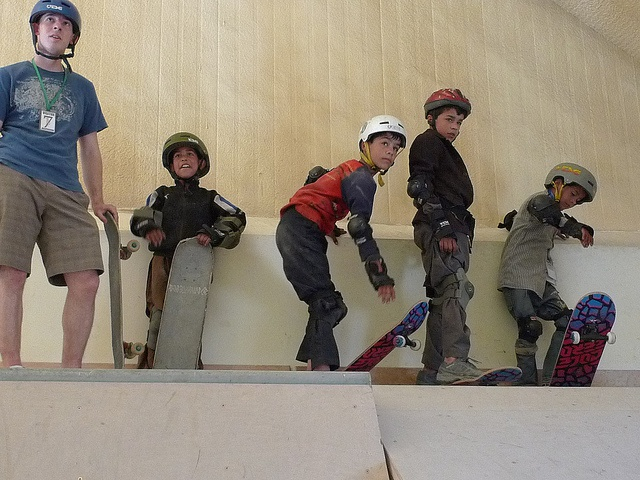Describe the objects in this image and their specific colors. I can see people in tan, gray, blue, and navy tones, people in tan, black, gray, and maroon tones, people in tan, black, and gray tones, people in tan, black, gray, and darkgray tones, and people in tan, black, gray, and maroon tones in this image. 